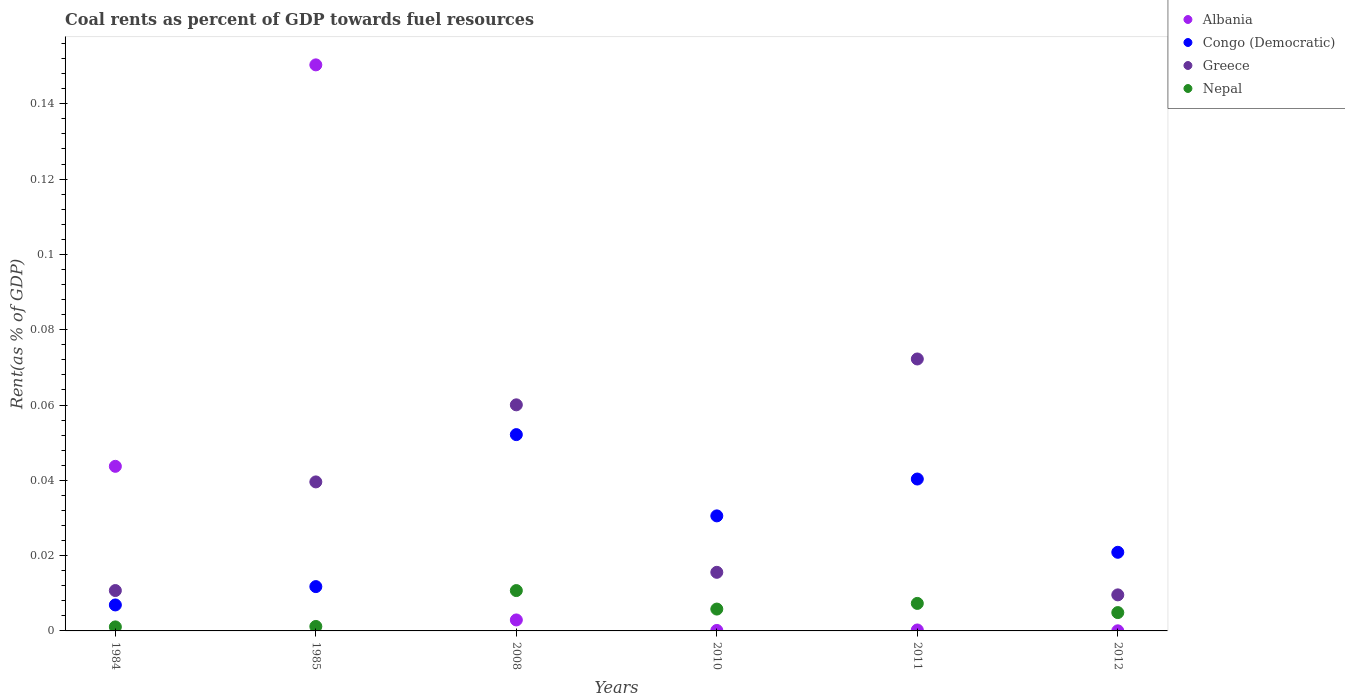How many different coloured dotlines are there?
Your answer should be very brief. 4. What is the coal rent in Congo (Democratic) in 1984?
Provide a succinct answer. 0.01. Across all years, what is the maximum coal rent in Congo (Democratic)?
Ensure brevity in your answer.  0.05. Across all years, what is the minimum coal rent in Congo (Democratic)?
Give a very brief answer. 0.01. In which year was the coal rent in Nepal minimum?
Provide a succinct answer. 1984. What is the total coal rent in Congo (Democratic) in the graph?
Provide a succinct answer. 0.16. What is the difference between the coal rent in Nepal in 2008 and that in 2010?
Provide a short and direct response. 0. What is the difference between the coal rent in Greece in 1984 and the coal rent in Albania in 2011?
Make the answer very short. 0.01. What is the average coal rent in Congo (Democratic) per year?
Offer a very short reply. 0.03. In the year 2011, what is the difference between the coal rent in Nepal and coal rent in Greece?
Your answer should be very brief. -0.06. In how many years, is the coal rent in Congo (Democratic) greater than 0.14800000000000002 %?
Keep it short and to the point. 0. What is the ratio of the coal rent in Greece in 1984 to that in 2011?
Your response must be concise. 0.15. Is the coal rent in Congo (Democratic) in 2011 less than that in 2012?
Make the answer very short. No. Is the difference between the coal rent in Nepal in 1984 and 2008 greater than the difference between the coal rent in Greece in 1984 and 2008?
Offer a very short reply. Yes. What is the difference between the highest and the second highest coal rent in Albania?
Keep it short and to the point. 0.11. What is the difference between the highest and the lowest coal rent in Greece?
Offer a very short reply. 0.06. In how many years, is the coal rent in Congo (Democratic) greater than the average coal rent in Congo (Democratic) taken over all years?
Your answer should be very brief. 3. Is the sum of the coal rent in Albania in 1984 and 2011 greater than the maximum coal rent in Nepal across all years?
Offer a terse response. Yes. Is it the case that in every year, the sum of the coal rent in Nepal and coal rent in Greece  is greater than the coal rent in Albania?
Give a very brief answer. No. Does the coal rent in Congo (Democratic) monotonically increase over the years?
Provide a short and direct response. No. Is the coal rent in Albania strictly less than the coal rent in Greece over the years?
Make the answer very short. No. What is the difference between two consecutive major ticks on the Y-axis?
Offer a terse response. 0.02. How are the legend labels stacked?
Offer a very short reply. Vertical. What is the title of the graph?
Provide a succinct answer. Coal rents as percent of GDP towards fuel resources. Does "Macao" appear as one of the legend labels in the graph?
Offer a terse response. No. What is the label or title of the Y-axis?
Provide a succinct answer. Rent(as % of GDP). What is the Rent(as % of GDP) in Albania in 1984?
Offer a terse response. 0.04. What is the Rent(as % of GDP) of Congo (Democratic) in 1984?
Ensure brevity in your answer.  0.01. What is the Rent(as % of GDP) of Greece in 1984?
Your response must be concise. 0.01. What is the Rent(as % of GDP) of Nepal in 1984?
Give a very brief answer. 0. What is the Rent(as % of GDP) of Albania in 1985?
Make the answer very short. 0.15. What is the Rent(as % of GDP) of Congo (Democratic) in 1985?
Ensure brevity in your answer.  0.01. What is the Rent(as % of GDP) of Greece in 1985?
Your answer should be compact. 0.04. What is the Rent(as % of GDP) in Nepal in 1985?
Offer a very short reply. 0. What is the Rent(as % of GDP) of Albania in 2008?
Ensure brevity in your answer.  0. What is the Rent(as % of GDP) of Congo (Democratic) in 2008?
Provide a succinct answer. 0.05. What is the Rent(as % of GDP) of Greece in 2008?
Provide a succinct answer. 0.06. What is the Rent(as % of GDP) of Nepal in 2008?
Provide a short and direct response. 0.01. What is the Rent(as % of GDP) of Albania in 2010?
Give a very brief answer. 0. What is the Rent(as % of GDP) of Congo (Democratic) in 2010?
Your answer should be very brief. 0.03. What is the Rent(as % of GDP) in Greece in 2010?
Keep it short and to the point. 0.02. What is the Rent(as % of GDP) of Nepal in 2010?
Provide a succinct answer. 0.01. What is the Rent(as % of GDP) of Albania in 2011?
Your response must be concise. 0. What is the Rent(as % of GDP) in Congo (Democratic) in 2011?
Provide a short and direct response. 0.04. What is the Rent(as % of GDP) of Greece in 2011?
Keep it short and to the point. 0.07. What is the Rent(as % of GDP) in Nepal in 2011?
Keep it short and to the point. 0.01. What is the Rent(as % of GDP) of Albania in 2012?
Make the answer very short. 2.82780495009493e-5. What is the Rent(as % of GDP) of Congo (Democratic) in 2012?
Provide a short and direct response. 0.02. What is the Rent(as % of GDP) in Greece in 2012?
Your answer should be compact. 0.01. What is the Rent(as % of GDP) in Nepal in 2012?
Ensure brevity in your answer.  0. Across all years, what is the maximum Rent(as % of GDP) of Albania?
Make the answer very short. 0.15. Across all years, what is the maximum Rent(as % of GDP) in Congo (Democratic)?
Your answer should be compact. 0.05. Across all years, what is the maximum Rent(as % of GDP) in Greece?
Make the answer very short. 0.07. Across all years, what is the maximum Rent(as % of GDP) in Nepal?
Offer a very short reply. 0.01. Across all years, what is the minimum Rent(as % of GDP) in Albania?
Offer a terse response. 2.82780495009493e-5. Across all years, what is the minimum Rent(as % of GDP) of Congo (Democratic)?
Keep it short and to the point. 0.01. Across all years, what is the minimum Rent(as % of GDP) of Greece?
Provide a short and direct response. 0.01. Across all years, what is the minimum Rent(as % of GDP) in Nepal?
Offer a terse response. 0. What is the total Rent(as % of GDP) of Albania in the graph?
Your answer should be compact. 0.2. What is the total Rent(as % of GDP) in Congo (Democratic) in the graph?
Offer a terse response. 0.16. What is the total Rent(as % of GDP) in Greece in the graph?
Offer a very short reply. 0.21. What is the total Rent(as % of GDP) of Nepal in the graph?
Offer a very short reply. 0.03. What is the difference between the Rent(as % of GDP) in Albania in 1984 and that in 1985?
Provide a succinct answer. -0.11. What is the difference between the Rent(as % of GDP) in Congo (Democratic) in 1984 and that in 1985?
Your answer should be very brief. -0. What is the difference between the Rent(as % of GDP) in Greece in 1984 and that in 1985?
Offer a very short reply. -0.03. What is the difference between the Rent(as % of GDP) of Nepal in 1984 and that in 1985?
Your response must be concise. -0. What is the difference between the Rent(as % of GDP) in Albania in 1984 and that in 2008?
Ensure brevity in your answer.  0.04. What is the difference between the Rent(as % of GDP) in Congo (Democratic) in 1984 and that in 2008?
Your answer should be compact. -0.05. What is the difference between the Rent(as % of GDP) in Greece in 1984 and that in 2008?
Your response must be concise. -0.05. What is the difference between the Rent(as % of GDP) of Nepal in 1984 and that in 2008?
Ensure brevity in your answer.  -0.01. What is the difference between the Rent(as % of GDP) in Albania in 1984 and that in 2010?
Offer a very short reply. 0.04. What is the difference between the Rent(as % of GDP) in Congo (Democratic) in 1984 and that in 2010?
Your answer should be compact. -0.02. What is the difference between the Rent(as % of GDP) of Greece in 1984 and that in 2010?
Offer a very short reply. -0. What is the difference between the Rent(as % of GDP) in Nepal in 1984 and that in 2010?
Offer a terse response. -0. What is the difference between the Rent(as % of GDP) in Albania in 1984 and that in 2011?
Your answer should be very brief. 0.04. What is the difference between the Rent(as % of GDP) of Congo (Democratic) in 1984 and that in 2011?
Keep it short and to the point. -0.03. What is the difference between the Rent(as % of GDP) in Greece in 1984 and that in 2011?
Your response must be concise. -0.06. What is the difference between the Rent(as % of GDP) in Nepal in 1984 and that in 2011?
Give a very brief answer. -0.01. What is the difference between the Rent(as % of GDP) of Albania in 1984 and that in 2012?
Give a very brief answer. 0.04. What is the difference between the Rent(as % of GDP) in Congo (Democratic) in 1984 and that in 2012?
Provide a short and direct response. -0.01. What is the difference between the Rent(as % of GDP) in Greece in 1984 and that in 2012?
Make the answer very short. 0. What is the difference between the Rent(as % of GDP) of Nepal in 1984 and that in 2012?
Provide a short and direct response. -0. What is the difference between the Rent(as % of GDP) of Albania in 1985 and that in 2008?
Your response must be concise. 0.15. What is the difference between the Rent(as % of GDP) in Congo (Democratic) in 1985 and that in 2008?
Provide a short and direct response. -0.04. What is the difference between the Rent(as % of GDP) of Greece in 1985 and that in 2008?
Provide a succinct answer. -0.02. What is the difference between the Rent(as % of GDP) in Nepal in 1985 and that in 2008?
Your answer should be very brief. -0.01. What is the difference between the Rent(as % of GDP) of Albania in 1985 and that in 2010?
Offer a very short reply. 0.15. What is the difference between the Rent(as % of GDP) in Congo (Democratic) in 1985 and that in 2010?
Give a very brief answer. -0.02. What is the difference between the Rent(as % of GDP) of Greece in 1985 and that in 2010?
Your answer should be very brief. 0.02. What is the difference between the Rent(as % of GDP) of Nepal in 1985 and that in 2010?
Keep it short and to the point. -0. What is the difference between the Rent(as % of GDP) in Albania in 1985 and that in 2011?
Give a very brief answer. 0.15. What is the difference between the Rent(as % of GDP) in Congo (Democratic) in 1985 and that in 2011?
Provide a short and direct response. -0.03. What is the difference between the Rent(as % of GDP) of Greece in 1985 and that in 2011?
Your answer should be very brief. -0.03. What is the difference between the Rent(as % of GDP) of Nepal in 1985 and that in 2011?
Offer a very short reply. -0.01. What is the difference between the Rent(as % of GDP) of Albania in 1985 and that in 2012?
Make the answer very short. 0.15. What is the difference between the Rent(as % of GDP) in Congo (Democratic) in 1985 and that in 2012?
Provide a succinct answer. -0.01. What is the difference between the Rent(as % of GDP) in Greece in 1985 and that in 2012?
Ensure brevity in your answer.  0.03. What is the difference between the Rent(as % of GDP) in Nepal in 1985 and that in 2012?
Offer a very short reply. -0. What is the difference between the Rent(as % of GDP) of Albania in 2008 and that in 2010?
Offer a very short reply. 0. What is the difference between the Rent(as % of GDP) in Congo (Democratic) in 2008 and that in 2010?
Offer a very short reply. 0.02. What is the difference between the Rent(as % of GDP) of Greece in 2008 and that in 2010?
Your response must be concise. 0.04. What is the difference between the Rent(as % of GDP) in Nepal in 2008 and that in 2010?
Your answer should be compact. 0. What is the difference between the Rent(as % of GDP) in Albania in 2008 and that in 2011?
Offer a very short reply. 0. What is the difference between the Rent(as % of GDP) of Congo (Democratic) in 2008 and that in 2011?
Make the answer very short. 0.01. What is the difference between the Rent(as % of GDP) of Greece in 2008 and that in 2011?
Keep it short and to the point. -0.01. What is the difference between the Rent(as % of GDP) in Nepal in 2008 and that in 2011?
Make the answer very short. 0. What is the difference between the Rent(as % of GDP) of Albania in 2008 and that in 2012?
Keep it short and to the point. 0. What is the difference between the Rent(as % of GDP) of Congo (Democratic) in 2008 and that in 2012?
Offer a terse response. 0.03. What is the difference between the Rent(as % of GDP) in Greece in 2008 and that in 2012?
Provide a succinct answer. 0.05. What is the difference between the Rent(as % of GDP) of Nepal in 2008 and that in 2012?
Offer a terse response. 0.01. What is the difference between the Rent(as % of GDP) in Albania in 2010 and that in 2011?
Your answer should be compact. -0. What is the difference between the Rent(as % of GDP) of Congo (Democratic) in 2010 and that in 2011?
Keep it short and to the point. -0.01. What is the difference between the Rent(as % of GDP) in Greece in 2010 and that in 2011?
Your answer should be compact. -0.06. What is the difference between the Rent(as % of GDP) in Nepal in 2010 and that in 2011?
Keep it short and to the point. -0. What is the difference between the Rent(as % of GDP) in Congo (Democratic) in 2010 and that in 2012?
Provide a succinct answer. 0.01. What is the difference between the Rent(as % of GDP) of Greece in 2010 and that in 2012?
Ensure brevity in your answer.  0.01. What is the difference between the Rent(as % of GDP) in Nepal in 2010 and that in 2012?
Provide a succinct answer. 0. What is the difference between the Rent(as % of GDP) of Congo (Democratic) in 2011 and that in 2012?
Ensure brevity in your answer.  0.02. What is the difference between the Rent(as % of GDP) in Greece in 2011 and that in 2012?
Offer a very short reply. 0.06. What is the difference between the Rent(as % of GDP) of Nepal in 2011 and that in 2012?
Offer a very short reply. 0. What is the difference between the Rent(as % of GDP) of Albania in 1984 and the Rent(as % of GDP) of Congo (Democratic) in 1985?
Offer a very short reply. 0.03. What is the difference between the Rent(as % of GDP) in Albania in 1984 and the Rent(as % of GDP) in Greece in 1985?
Provide a succinct answer. 0. What is the difference between the Rent(as % of GDP) in Albania in 1984 and the Rent(as % of GDP) in Nepal in 1985?
Provide a succinct answer. 0.04. What is the difference between the Rent(as % of GDP) in Congo (Democratic) in 1984 and the Rent(as % of GDP) in Greece in 1985?
Your answer should be very brief. -0.03. What is the difference between the Rent(as % of GDP) of Congo (Democratic) in 1984 and the Rent(as % of GDP) of Nepal in 1985?
Your answer should be very brief. 0.01. What is the difference between the Rent(as % of GDP) in Greece in 1984 and the Rent(as % of GDP) in Nepal in 1985?
Keep it short and to the point. 0.01. What is the difference between the Rent(as % of GDP) in Albania in 1984 and the Rent(as % of GDP) in Congo (Democratic) in 2008?
Your answer should be very brief. -0.01. What is the difference between the Rent(as % of GDP) in Albania in 1984 and the Rent(as % of GDP) in Greece in 2008?
Ensure brevity in your answer.  -0.02. What is the difference between the Rent(as % of GDP) in Albania in 1984 and the Rent(as % of GDP) in Nepal in 2008?
Keep it short and to the point. 0.03. What is the difference between the Rent(as % of GDP) of Congo (Democratic) in 1984 and the Rent(as % of GDP) of Greece in 2008?
Keep it short and to the point. -0.05. What is the difference between the Rent(as % of GDP) of Congo (Democratic) in 1984 and the Rent(as % of GDP) of Nepal in 2008?
Provide a succinct answer. -0. What is the difference between the Rent(as % of GDP) of Greece in 1984 and the Rent(as % of GDP) of Nepal in 2008?
Provide a succinct answer. 0. What is the difference between the Rent(as % of GDP) in Albania in 1984 and the Rent(as % of GDP) in Congo (Democratic) in 2010?
Keep it short and to the point. 0.01. What is the difference between the Rent(as % of GDP) in Albania in 1984 and the Rent(as % of GDP) in Greece in 2010?
Offer a terse response. 0.03. What is the difference between the Rent(as % of GDP) of Albania in 1984 and the Rent(as % of GDP) of Nepal in 2010?
Your answer should be compact. 0.04. What is the difference between the Rent(as % of GDP) of Congo (Democratic) in 1984 and the Rent(as % of GDP) of Greece in 2010?
Keep it short and to the point. -0.01. What is the difference between the Rent(as % of GDP) of Congo (Democratic) in 1984 and the Rent(as % of GDP) of Nepal in 2010?
Your response must be concise. 0. What is the difference between the Rent(as % of GDP) in Greece in 1984 and the Rent(as % of GDP) in Nepal in 2010?
Give a very brief answer. 0. What is the difference between the Rent(as % of GDP) of Albania in 1984 and the Rent(as % of GDP) of Congo (Democratic) in 2011?
Offer a terse response. 0. What is the difference between the Rent(as % of GDP) in Albania in 1984 and the Rent(as % of GDP) in Greece in 2011?
Your answer should be very brief. -0.03. What is the difference between the Rent(as % of GDP) in Albania in 1984 and the Rent(as % of GDP) in Nepal in 2011?
Offer a very short reply. 0.04. What is the difference between the Rent(as % of GDP) in Congo (Democratic) in 1984 and the Rent(as % of GDP) in Greece in 2011?
Provide a short and direct response. -0.07. What is the difference between the Rent(as % of GDP) in Congo (Democratic) in 1984 and the Rent(as % of GDP) in Nepal in 2011?
Give a very brief answer. -0. What is the difference between the Rent(as % of GDP) in Greece in 1984 and the Rent(as % of GDP) in Nepal in 2011?
Ensure brevity in your answer.  0. What is the difference between the Rent(as % of GDP) of Albania in 1984 and the Rent(as % of GDP) of Congo (Democratic) in 2012?
Your answer should be compact. 0.02. What is the difference between the Rent(as % of GDP) of Albania in 1984 and the Rent(as % of GDP) of Greece in 2012?
Make the answer very short. 0.03. What is the difference between the Rent(as % of GDP) in Albania in 1984 and the Rent(as % of GDP) in Nepal in 2012?
Your response must be concise. 0.04. What is the difference between the Rent(as % of GDP) in Congo (Democratic) in 1984 and the Rent(as % of GDP) in Greece in 2012?
Offer a very short reply. -0. What is the difference between the Rent(as % of GDP) of Congo (Democratic) in 1984 and the Rent(as % of GDP) of Nepal in 2012?
Provide a short and direct response. 0. What is the difference between the Rent(as % of GDP) of Greece in 1984 and the Rent(as % of GDP) of Nepal in 2012?
Ensure brevity in your answer.  0.01. What is the difference between the Rent(as % of GDP) in Albania in 1985 and the Rent(as % of GDP) in Congo (Democratic) in 2008?
Ensure brevity in your answer.  0.1. What is the difference between the Rent(as % of GDP) in Albania in 1985 and the Rent(as % of GDP) in Greece in 2008?
Keep it short and to the point. 0.09. What is the difference between the Rent(as % of GDP) in Albania in 1985 and the Rent(as % of GDP) in Nepal in 2008?
Your response must be concise. 0.14. What is the difference between the Rent(as % of GDP) in Congo (Democratic) in 1985 and the Rent(as % of GDP) in Greece in 2008?
Your answer should be compact. -0.05. What is the difference between the Rent(as % of GDP) in Congo (Democratic) in 1985 and the Rent(as % of GDP) in Nepal in 2008?
Offer a terse response. 0. What is the difference between the Rent(as % of GDP) in Greece in 1985 and the Rent(as % of GDP) in Nepal in 2008?
Make the answer very short. 0.03. What is the difference between the Rent(as % of GDP) of Albania in 1985 and the Rent(as % of GDP) of Congo (Democratic) in 2010?
Provide a short and direct response. 0.12. What is the difference between the Rent(as % of GDP) in Albania in 1985 and the Rent(as % of GDP) in Greece in 2010?
Keep it short and to the point. 0.13. What is the difference between the Rent(as % of GDP) of Albania in 1985 and the Rent(as % of GDP) of Nepal in 2010?
Make the answer very short. 0.14. What is the difference between the Rent(as % of GDP) in Congo (Democratic) in 1985 and the Rent(as % of GDP) in Greece in 2010?
Provide a short and direct response. -0. What is the difference between the Rent(as % of GDP) in Congo (Democratic) in 1985 and the Rent(as % of GDP) in Nepal in 2010?
Offer a terse response. 0.01. What is the difference between the Rent(as % of GDP) in Greece in 1985 and the Rent(as % of GDP) in Nepal in 2010?
Offer a very short reply. 0.03. What is the difference between the Rent(as % of GDP) of Albania in 1985 and the Rent(as % of GDP) of Congo (Democratic) in 2011?
Provide a short and direct response. 0.11. What is the difference between the Rent(as % of GDP) of Albania in 1985 and the Rent(as % of GDP) of Greece in 2011?
Offer a very short reply. 0.08. What is the difference between the Rent(as % of GDP) of Albania in 1985 and the Rent(as % of GDP) of Nepal in 2011?
Your answer should be very brief. 0.14. What is the difference between the Rent(as % of GDP) in Congo (Democratic) in 1985 and the Rent(as % of GDP) in Greece in 2011?
Offer a terse response. -0.06. What is the difference between the Rent(as % of GDP) of Congo (Democratic) in 1985 and the Rent(as % of GDP) of Nepal in 2011?
Give a very brief answer. 0. What is the difference between the Rent(as % of GDP) in Greece in 1985 and the Rent(as % of GDP) in Nepal in 2011?
Provide a short and direct response. 0.03. What is the difference between the Rent(as % of GDP) in Albania in 1985 and the Rent(as % of GDP) in Congo (Democratic) in 2012?
Keep it short and to the point. 0.13. What is the difference between the Rent(as % of GDP) of Albania in 1985 and the Rent(as % of GDP) of Greece in 2012?
Keep it short and to the point. 0.14. What is the difference between the Rent(as % of GDP) in Albania in 1985 and the Rent(as % of GDP) in Nepal in 2012?
Provide a short and direct response. 0.15. What is the difference between the Rent(as % of GDP) of Congo (Democratic) in 1985 and the Rent(as % of GDP) of Greece in 2012?
Make the answer very short. 0. What is the difference between the Rent(as % of GDP) in Congo (Democratic) in 1985 and the Rent(as % of GDP) in Nepal in 2012?
Provide a succinct answer. 0.01. What is the difference between the Rent(as % of GDP) in Greece in 1985 and the Rent(as % of GDP) in Nepal in 2012?
Keep it short and to the point. 0.03. What is the difference between the Rent(as % of GDP) in Albania in 2008 and the Rent(as % of GDP) in Congo (Democratic) in 2010?
Give a very brief answer. -0.03. What is the difference between the Rent(as % of GDP) in Albania in 2008 and the Rent(as % of GDP) in Greece in 2010?
Keep it short and to the point. -0.01. What is the difference between the Rent(as % of GDP) of Albania in 2008 and the Rent(as % of GDP) of Nepal in 2010?
Your answer should be very brief. -0. What is the difference between the Rent(as % of GDP) in Congo (Democratic) in 2008 and the Rent(as % of GDP) in Greece in 2010?
Make the answer very short. 0.04. What is the difference between the Rent(as % of GDP) in Congo (Democratic) in 2008 and the Rent(as % of GDP) in Nepal in 2010?
Offer a very short reply. 0.05. What is the difference between the Rent(as % of GDP) of Greece in 2008 and the Rent(as % of GDP) of Nepal in 2010?
Offer a very short reply. 0.05. What is the difference between the Rent(as % of GDP) in Albania in 2008 and the Rent(as % of GDP) in Congo (Democratic) in 2011?
Provide a succinct answer. -0.04. What is the difference between the Rent(as % of GDP) in Albania in 2008 and the Rent(as % of GDP) in Greece in 2011?
Make the answer very short. -0.07. What is the difference between the Rent(as % of GDP) in Albania in 2008 and the Rent(as % of GDP) in Nepal in 2011?
Ensure brevity in your answer.  -0. What is the difference between the Rent(as % of GDP) of Congo (Democratic) in 2008 and the Rent(as % of GDP) of Greece in 2011?
Provide a succinct answer. -0.02. What is the difference between the Rent(as % of GDP) of Congo (Democratic) in 2008 and the Rent(as % of GDP) of Nepal in 2011?
Give a very brief answer. 0.04. What is the difference between the Rent(as % of GDP) of Greece in 2008 and the Rent(as % of GDP) of Nepal in 2011?
Provide a succinct answer. 0.05. What is the difference between the Rent(as % of GDP) in Albania in 2008 and the Rent(as % of GDP) in Congo (Democratic) in 2012?
Keep it short and to the point. -0.02. What is the difference between the Rent(as % of GDP) of Albania in 2008 and the Rent(as % of GDP) of Greece in 2012?
Provide a short and direct response. -0.01. What is the difference between the Rent(as % of GDP) of Albania in 2008 and the Rent(as % of GDP) of Nepal in 2012?
Make the answer very short. -0. What is the difference between the Rent(as % of GDP) in Congo (Democratic) in 2008 and the Rent(as % of GDP) in Greece in 2012?
Offer a very short reply. 0.04. What is the difference between the Rent(as % of GDP) in Congo (Democratic) in 2008 and the Rent(as % of GDP) in Nepal in 2012?
Provide a succinct answer. 0.05. What is the difference between the Rent(as % of GDP) in Greece in 2008 and the Rent(as % of GDP) in Nepal in 2012?
Offer a very short reply. 0.06. What is the difference between the Rent(as % of GDP) of Albania in 2010 and the Rent(as % of GDP) of Congo (Democratic) in 2011?
Provide a short and direct response. -0.04. What is the difference between the Rent(as % of GDP) in Albania in 2010 and the Rent(as % of GDP) in Greece in 2011?
Offer a terse response. -0.07. What is the difference between the Rent(as % of GDP) of Albania in 2010 and the Rent(as % of GDP) of Nepal in 2011?
Offer a terse response. -0.01. What is the difference between the Rent(as % of GDP) of Congo (Democratic) in 2010 and the Rent(as % of GDP) of Greece in 2011?
Your answer should be compact. -0.04. What is the difference between the Rent(as % of GDP) of Congo (Democratic) in 2010 and the Rent(as % of GDP) of Nepal in 2011?
Provide a short and direct response. 0.02. What is the difference between the Rent(as % of GDP) in Greece in 2010 and the Rent(as % of GDP) in Nepal in 2011?
Offer a terse response. 0.01. What is the difference between the Rent(as % of GDP) in Albania in 2010 and the Rent(as % of GDP) in Congo (Democratic) in 2012?
Provide a short and direct response. -0.02. What is the difference between the Rent(as % of GDP) in Albania in 2010 and the Rent(as % of GDP) in Greece in 2012?
Ensure brevity in your answer.  -0.01. What is the difference between the Rent(as % of GDP) of Albania in 2010 and the Rent(as % of GDP) of Nepal in 2012?
Your answer should be compact. -0. What is the difference between the Rent(as % of GDP) in Congo (Democratic) in 2010 and the Rent(as % of GDP) in Greece in 2012?
Your answer should be compact. 0.02. What is the difference between the Rent(as % of GDP) in Congo (Democratic) in 2010 and the Rent(as % of GDP) in Nepal in 2012?
Offer a very short reply. 0.03. What is the difference between the Rent(as % of GDP) in Greece in 2010 and the Rent(as % of GDP) in Nepal in 2012?
Offer a terse response. 0.01. What is the difference between the Rent(as % of GDP) in Albania in 2011 and the Rent(as % of GDP) in Congo (Democratic) in 2012?
Give a very brief answer. -0.02. What is the difference between the Rent(as % of GDP) of Albania in 2011 and the Rent(as % of GDP) of Greece in 2012?
Offer a terse response. -0.01. What is the difference between the Rent(as % of GDP) in Albania in 2011 and the Rent(as % of GDP) in Nepal in 2012?
Provide a succinct answer. -0. What is the difference between the Rent(as % of GDP) of Congo (Democratic) in 2011 and the Rent(as % of GDP) of Greece in 2012?
Give a very brief answer. 0.03. What is the difference between the Rent(as % of GDP) in Congo (Democratic) in 2011 and the Rent(as % of GDP) in Nepal in 2012?
Your response must be concise. 0.04. What is the difference between the Rent(as % of GDP) of Greece in 2011 and the Rent(as % of GDP) of Nepal in 2012?
Your answer should be very brief. 0.07. What is the average Rent(as % of GDP) in Albania per year?
Offer a very short reply. 0.03. What is the average Rent(as % of GDP) in Congo (Democratic) per year?
Offer a terse response. 0.03. What is the average Rent(as % of GDP) in Greece per year?
Offer a very short reply. 0.03. What is the average Rent(as % of GDP) in Nepal per year?
Your answer should be compact. 0.01. In the year 1984, what is the difference between the Rent(as % of GDP) in Albania and Rent(as % of GDP) in Congo (Democratic)?
Provide a short and direct response. 0.04. In the year 1984, what is the difference between the Rent(as % of GDP) of Albania and Rent(as % of GDP) of Greece?
Keep it short and to the point. 0.03. In the year 1984, what is the difference between the Rent(as % of GDP) of Albania and Rent(as % of GDP) of Nepal?
Ensure brevity in your answer.  0.04. In the year 1984, what is the difference between the Rent(as % of GDP) in Congo (Democratic) and Rent(as % of GDP) in Greece?
Make the answer very short. -0. In the year 1984, what is the difference between the Rent(as % of GDP) of Congo (Democratic) and Rent(as % of GDP) of Nepal?
Offer a very short reply. 0.01. In the year 1984, what is the difference between the Rent(as % of GDP) in Greece and Rent(as % of GDP) in Nepal?
Your response must be concise. 0.01. In the year 1985, what is the difference between the Rent(as % of GDP) in Albania and Rent(as % of GDP) in Congo (Democratic)?
Provide a succinct answer. 0.14. In the year 1985, what is the difference between the Rent(as % of GDP) in Albania and Rent(as % of GDP) in Greece?
Keep it short and to the point. 0.11. In the year 1985, what is the difference between the Rent(as % of GDP) in Albania and Rent(as % of GDP) in Nepal?
Make the answer very short. 0.15. In the year 1985, what is the difference between the Rent(as % of GDP) in Congo (Democratic) and Rent(as % of GDP) in Greece?
Ensure brevity in your answer.  -0.03. In the year 1985, what is the difference between the Rent(as % of GDP) in Congo (Democratic) and Rent(as % of GDP) in Nepal?
Offer a terse response. 0.01. In the year 1985, what is the difference between the Rent(as % of GDP) in Greece and Rent(as % of GDP) in Nepal?
Provide a short and direct response. 0.04. In the year 2008, what is the difference between the Rent(as % of GDP) of Albania and Rent(as % of GDP) of Congo (Democratic)?
Provide a succinct answer. -0.05. In the year 2008, what is the difference between the Rent(as % of GDP) in Albania and Rent(as % of GDP) in Greece?
Provide a short and direct response. -0.06. In the year 2008, what is the difference between the Rent(as % of GDP) of Albania and Rent(as % of GDP) of Nepal?
Your answer should be very brief. -0.01. In the year 2008, what is the difference between the Rent(as % of GDP) in Congo (Democratic) and Rent(as % of GDP) in Greece?
Your answer should be compact. -0.01. In the year 2008, what is the difference between the Rent(as % of GDP) of Congo (Democratic) and Rent(as % of GDP) of Nepal?
Offer a terse response. 0.04. In the year 2008, what is the difference between the Rent(as % of GDP) of Greece and Rent(as % of GDP) of Nepal?
Your answer should be compact. 0.05. In the year 2010, what is the difference between the Rent(as % of GDP) of Albania and Rent(as % of GDP) of Congo (Democratic)?
Ensure brevity in your answer.  -0.03. In the year 2010, what is the difference between the Rent(as % of GDP) in Albania and Rent(as % of GDP) in Greece?
Offer a very short reply. -0.02. In the year 2010, what is the difference between the Rent(as % of GDP) in Albania and Rent(as % of GDP) in Nepal?
Offer a terse response. -0.01. In the year 2010, what is the difference between the Rent(as % of GDP) in Congo (Democratic) and Rent(as % of GDP) in Greece?
Ensure brevity in your answer.  0.01. In the year 2010, what is the difference between the Rent(as % of GDP) of Congo (Democratic) and Rent(as % of GDP) of Nepal?
Make the answer very short. 0.02. In the year 2010, what is the difference between the Rent(as % of GDP) in Greece and Rent(as % of GDP) in Nepal?
Your answer should be compact. 0.01. In the year 2011, what is the difference between the Rent(as % of GDP) of Albania and Rent(as % of GDP) of Congo (Democratic)?
Offer a very short reply. -0.04. In the year 2011, what is the difference between the Rent(as % of GDP) of Albania and Rent(as % of GDP) of Greece?
Keep it short and to the point. -0.07. In the year 2011, what is the difference between the Rent(as % of GDP) in Albania and Rent(as % of GDP) in Nepal?
Offer a terse response. -0.01. In the year 2011, what is the difference between the Rent(as % of GDP) in Congo (Democratic) and Rent(as % of GDP) in Greece?
Provide a short and direct response. -0.03. In the year 2011, what is the difference between the Rent(as % of GDP) in Congo (Democratic) and Rent(as % of GDP) in Nepal?
Offer a very short reply. 0.03. In the year 2011, what is the difference between the Rent(as % of GDP) of Greece and Rent(as % of GDP) of Nepal?
Keep it short and to the point. 0.06. In the year 2012, what is the difference between the Rent(as % of GDP) of Albania and Rent(as % of GDP) of Congo (Democratic)?
Offer a very short reply. -0.02. In the year 2012, what is the difference between the Rent(as % of GDP) of Albania and Rent(as % of GDP) of Greece?
Your response must be concise. -0.01. In the year 2012, what is the difference between the Rent(as % of GDP) of Albania and Rent(as % of GDP) of Nepal?
Keep it short and to the point. -0. In the year 2012, what is the difference between the Rent(as % of GDP) in Congo (Democratic) and Rent(as % of GDP) in Greece?
Provide a succinct answer. 0.01. In the year 2012, what is the difference between the Rent(as % of GDP) of Congo (Democratic) and Rent(as % of GDP) of Nepal?
Provide a succinct answer. 0.02. In the year 2012, what is the difference between the Rent(as % of GDP) in Greece and Rent(as % of GDP) in Nepal?
Offer a terse response. 0. What is the ratio of the Rent(as % of GDP) of Albania in 1984 to that in 1985?
Your answer should be compact. 0.29. What is the ratio of the Rent(as % of GDP) of Congo (Democratic) in 1984 to that in 1985?
Give a very brief answer. 0.59. What is the ratio of the Rent(as % of GDP) of Greece in 1984 to that in 1985?
Your answer should be very brief. 0.27. What is the ratio of the Rent(as % of GDP) in Nepal in 1984 to that in 1985?
Make the answer very short. 0.9. What is the ratio of the Rent(as % of GDP) in Albania in 1984 to that in 2008?
Keep it short and to the point. 14.99. What is the ratio of the Rent(as % of GDP) in Congo (Democratic) in 1984 to that in 2008?
Your answer should be compact. 0.13. What is the ratio of the Rent(as % of GDP) in Greece in 1984 to that in 2008?
Your answer should be very brief. 0.18. What is the ratio of the Rent(as % of GDP) of Nepal in 1984 to that in 2008?
Your answer should be very brief. 0.1. What is the ratio of the Rent(as % of GDP) in Albania in 1984 to that in 2010?
Make the answer very short. 347.91. What is the ratio of the Rent(as % of GDP) of Congo (Democratic) in 1984 to that in 2010?
Ensure brevity in your answer.  0.23. What is the ratio of the Rent(as % of GDP) of Greece in 1984 to that in 2010?
Provide a short and direct response. 0.69. What is the ratio of the Rent(as % of GDP) of Nepal in 1984 to that in 2010?
Provide a short and direct response. 0.18. What is the ratio of the Rent(as % of GDP) of Albania in 1984 to that in 2011?
Ensure brevity in your answer.  172.49. What is the ratio of the Rent(as % of GDP) in Congo (Democratic) in 1984 to that in 2011?
Make the answer very short. 0.17. What is the ratio of the Rent(as % of GDP) of Greece in 1984 to that in 2011?
Make the answer very short. 0.15. What is the ratio of the Rent(as % of GDP) of Nepal in 1984 to that in 2011?
Offer a terse response. 0.15. What is the ratio of the Rent(as % of GDP) in Albania in 1984 to that in 2012?
Keep it short and to the point. 1545.91. What is the ratio of the Rent(as % of GDP) in Congo (Democratic) in 1984 to that in 2012?
Your answer should be compact. 0.33. What is the ratio of the Rent(as % of GDP) in Greece in 1984 to that in 2012?
Provide a succinct answer. 1.12. What is the ratio of the Rent(as % of GDP) of Nepal in 1984 to that in 2012?
Ensure brevity in your answer.  0.22. What is the ratio of the Rent(as % of GDP) of Albania in 1985 to that in 2008?
Keep it short and to the point. 51.55. What is the ratio of the Rent(as % of GDP) of Congo (Democratic) in 1985 to that in 2008?
Your response must be concise. 0.23. What is the ratio of the Rent(as % of GDP) in Greece in 1985 to that in 2008?
Offer a very short reply. 0.66. What is the ratio of the Rent(as % of GDP) of Nepal in 1985 to that in 2008?
Your response must be concise. 0.11. What is the ratio of the Rent(as % of GDP) of Albania in 1985 to that in 2010?
Give a very brief answer. 1196.46. What is the ratio of the Rent(as % of GDP) of Congo (Democratic) in 1985 to that in 2010?
Offer a terse response. 0.39. What is the ratio of the Rent(as % of GDP) in Greece in 1985 to that in 2010?
Your response must be concise. 2.54. What is the ratio of the Rent(as % of GDP) of Nepal in 1985 to that in 2010?
Offer a terse response. 0.2. What is the ratio of the Rent(as % of GDP) of Albania in 1985 to that in 2011?
Give a very brief answer. 593.21. What is the ratio of the Rent(as % of GDP) in Congo (Democratic) in 1985 to that in 2011?
Provide a succinct answer. 0.29. What is the ratio of the Rent(as % of GDP) in Greece in 1985 to that in 2011?
Give a very brief answer. 0.55. What is the ratio of the Rent(as % of GDP) in Nepal in 1985 to that in 2011?
Provide a succinct answer. 0.16. What is the ratio of the Rent(as % of GDP) in Albania in 1985 to that in 2012?
Your response must be concise. 5316.45. What is the ratio of the Rent(as % of GDP) in Congo (Democratic) in 1985 to that in 2012?
Keep it short and to the point. 0.56. What is the ratio of the Rent(as % of GDP) of Greece in 1985 to that in 2012?
Your response must be concise. 4.13. What is the ratio of the Rent(as % of GDP) of Nepal in 1985 to that in 2012?
Ensure brevity in your answer.  0.24. What is the ratio of the Rent(as % of GDP) in Albania in 2008 to that in 2010?
Offer a very short reply. 23.21. What is the ratio of the Rent(as % of GDP) of Congo (Democratic) in 2008 to that in 2010?
Give a very brief answer. 1.71. What is the ratio of the Rent(as % of GDP) of Greece in 2008 to that in 2010?
Keep it short and to the point. 3.86. What is the ratio of the Rent(as % of GDP) in Nepal in 2008 to that in 2010?
Offer a terse response. 1.85. What is the ratio of the Rent(as % of GDP) in Albania in 2008 to that in 2011?
Offer a terse response. 11.51. What is the ratio of the Rent(as % of GDP) of Congo (Democratic) in 2008 to that in 2011?
Your response must be concise. 1.29. What is the ratio of the Rent(as % of GDP) in Greece in 2008 to that in 2011?
Offer a very short reply. 0.83. What is the ratio of the Rent(as % of GDP) of Nepal in 2008 to that in 2011?
Keep it short and to the point. 1.47. What is the ratio of the Rent(as % of GDP) of Albania in 2008 to that in 2012?
Offer a very short reply. 103.12. What is the ratio of the Rent(as % of GDP) of Congo (Democratic) in 2008 to that in 2012?
Your response must be concise. 2.5. What is the ratio of the Rent(as % of GDP) of Greece in 2008 to that in 2012?
Your answer should be very brief. 6.27. What is the ratio of the Rent(as % of GDP) in Nepal in 2008 to that in 2012?
Provide a succinct answer. 2.2. What is the ratio of the Rent(as % of GDP) of Albania in 2010 to that in 2011?
Ensure brevity in your answer.  0.5. What is the ratio of the Rent(as % of GDP) in Congo (Democratic) in 2010 to that in 2011?
Provide a succinct answer. 0.76. What is the ratio of the Rent(as % of GDP) of Greece in 2010 to that in 2011?
Ensure brevity in your answer.  0.22. What is the ratio of the Rent(as % of GDP) in Nepal in 2010 to that in 2011?
Provide a short and direct response. 0.79. What is the ratio of the Rent(as % of GDP) of Albania in 2010 to that in 2012?
Provide a short and direct response. 4.44. What is the ratio of the Rent(as % of GDP) in Congo (Democratic) in 2010 to that in 2012?
Provide a short and direct response. 1.46. What is the ratio of the Rent(as % of GDP) of Greece in 2010 to that in 2012?
Offer a terse response. 1.63. What is the ratio of the Rent(as % of GDP) of Nepal in 2010 to that in 2012?
Your answer should be compact. 1.19. What is the ratio of the Rent(as % of GDP) of Albania in 2011 to that in 2012?
Your answer should be compact. 8.96. What is the ratio of the Rent(as % of GDP) in Congo (Democratic) in 2011 to that in 2012?
Your answer should be very brief. 1.93. What is the ratio of the Rent(as % of GDP) of Greece in 2011 to that in 2012?
Make the answer very short. 7.54. What is the ratio of the Rent(as % of GDP) of Nepal in 2011 to that in 2012?
Offer a terse response. 1.5. What is the difference between the highest and the second highest Rent(as % of GDP) in Albania?
Offer a terse response. 0.11. What is the difference between the highest and the second highest Rent(as % of GDP) in Congo (Democratic)?
Ensure brevity in your answer.  0.01. What is the difference between the highest and the second highest Rent(as % of GDP) in Greece?
Offer a very short reply. 0.01. What is the difference between the highest and the second highest Rent(as % of GDP) in Nepal?
Ensure brevity in your answer.  0. What is the difference between the highest and the lowest Rent(as % of GDP) of Albania?
Provide a short and direct response. 0.15. What is the difference between the highest and the lowest Rent(as % of GDP) of Congo (Democratic)?
Offer a terse response. 0.05. What is the difference between the highest and the lowest Rent(as % of GDP) of Greece?
Keep it short and to the point. 0.06. What is the difference between the highest and the lowest Rent(as % of GDP) in Nepal?
Your answer should be compact. 0.01. 